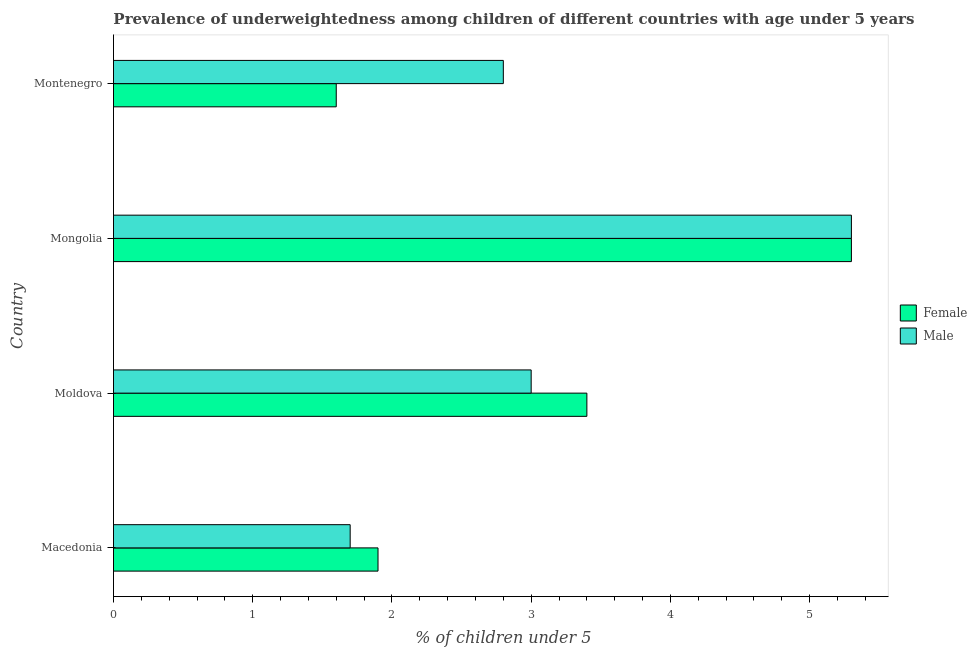How many different coloured bars are there?
Offer a very short reply. 2. Are the number of bars on each tick of the Y-axis equal?
Your answer should be very brief. Yes. How many bars are there on the 1st tick from the bottom?
Provide a short and direct response. 2. What is the label of the 1st group of bars from the top?
Keep it short and to the point. Montenegro. In how many cases, is the number of bars for a given country not equal to the number of legend labels?
Make the answer very short. 0. What is the percentage of underweighted male children in Moldova?
Your answer should be compact. 3. Across all countries, what is the maximum percentage of underweighted male children?
Your answer should be very brief. 5.3. Across all countries, what is the minimum percentage of underweighted female children?
Offer a very short reply. 1.6. In which country was the percentage of underweighted female children maximum?
Your answer should be compact. Mongolia. In which country was the percentage of underweighted female children minimum?
Your response must be concise. Montenegro. What is the total percentage of underweighted male children in the graph?
Offer a very short reply. 12.8. What is the difference between the percentage of underweighted male children in Moldova and that in Montenegro?
Provide a succinct answer. 0.2. What is the difference between the percentage of underweighted male children in Mongolia and the percentage of underweighted female children in Macedonia?
Your answer should be compact. 3.4. What is the average percentage of underweighted male children per country?
Keep it short and to the point. 3.2. What is the ratio of the percentage of underweighted female children in Macedonia to that in Mongolia?
Keep it short and to the point. 0.36. Is the percentage of underweighted female children in Macedonia less than that in Moldova?
Provide a succinct answer. Yes. Is the difference between the percentage of underweighted female children in Moldova and Mongolia greater than the difference between the percentage of underweighted male children in Moldova and Mongolia?
Your response must be concise. Yes. In how many countries, is the percentage of underweighted female children greater than the average percentage of underweighted female children taken over all countries?
Offer a very short reply. 2. Is the sum of the percentage of underweighted male children in Moldova and Mongolia greater than the maximum percentage of underweighted female children across all countries?
Your response must be concise. Yes. What does the 1st bar from the top in Montenegro represents?
Your response must be concise. Male. What does the 2nd bar from the bottom in Montenegro represents?
Make the answer very short. Male. How many bars are there?
Provide a succinct answer. 8. Are all the bars in the graph horizontal?
Offer a very short reply. Yes. Does the graph contain any zero values?
Your response must be concise. No. Where does the legend appear in the graph?
Offer a terse response. Center right. What is the title of the graph?
Keep it short and to the point. Prevalence of underweightedness among children of different countries with age under 5 years. Does "Canada" appear as one of the legend labels in the graph?
Your response must be concise. No. What is the label or title of the X-axis?
Offer a very short reply.  % of children under 5. What is the label or title of the Y-axis?
Offer a very short reply. Country. What is the  % of children under 5 in Female in Macedonia?
Offer a terse response. 1.9. What is the  % of children under 5 in Male in Macedonia?
Your response must be concise. 1.7. What is the  % of children under 5 of Female in Moldova?
Keep it short and to the point. 3.4. What is the  % of children under 5 of Female in Mongolia?
Offer a terse response. 5.3. What is the  % of children under 5 of Male in Mongolia?
Offer a very short reply. 5.3. What is the  % of children under 5 in Female in Montenegro?
Offer a very short reply. 1.6. What is the  % of children under 5 in Male in Montenegro?
Your answer should be compact. 2.8. Across all countries, what is the maximum  % of children under 5 of Female?
Provide a short and direct response. 5.3. Across all countries, what is the maximum  % of children under 5 of Male?
Your response must be concise. 5.3. Across all countries, what is the minimum  % of children under 5 in Female?
Your response must be concise. 1.6. Across all countries, what is the minimum  % of children under 5 in Male?
Provide a short and direct response. 1.7. What is the total  % of children under 5 in Female in the graph?
Give a very brief answer. 12.2. What is the difference between the  % of children under 5 of Male in Macedonia and that in Moldova?
Ensure brevity in your answer.  -1.3. What is the difference between the  % of children under 5 of Female in Macedonia and that in Mongolia?
Make the answer very short. -3.4. What is the difference between the  % of children under 5 in Male in Macedonia and that in Mongolia?
Provide a succinct answer. -3.6. What is the difference between the  % of children under 5 of Female in Macedonia and that in Montenegro?
Keep it short and to the point. 0.3. What is the difference between the  % of children under 5 of Male in Macedonia and that in Montenegro?
Offer a very short reply. -1.1. What is the difference between the  % of children under 5 of Male in Moldova and that in Mongolia?
Your answer should be compact. -2.3. What is the difference between the  % of children under 5 of Female in Moldova and that in Montenegro?
Your answer should be very brief. 1.8. What is the difference between the  % of children under 5 of Male in Moldova and that in Montenegro?
Ensure brevity in your answer.  0.2. What is the difference between the  % of children under 5 of Female in Mongolia and that in Montenegro?
Provide a short and direct response. 3.7. What is the difference between the  % of children under 5 in Male in Mongolia and that in Montenegro?
Offer a very short reply. 2.5. What is the difference between the  % of children under 5 of Female in Macedonia and the  % of children under 5 of Male in Mongolia?
Keep it short and to the point. -3.4. What is the difference between the  % of children under 5 of Female in Moldova and the  % of children under 5 of Male in Montenegro?
Your answer should be very brief. 0.6. What is the average  % of children under 5 of Female per country?
Provide a succinct answer. 3.05. What is the difference between the  % of children under 5 in Female and  % of children under 5 in Male in Macedonia?
Your answer should be very brief. 0.2. What is the difference between the  % of children under 5 in Female and  % of children under 5 in Male in Mongolia?
Give a very brief answer. 0. What is the difference between the  % of children under 5 in Female and  % of children under 5 in Male in Montenegro?
Make the answer very short. -1.2. What is the ratio of the  % of children under 5 in Female in Macedonia to that in Moldova?
Keep it short and to the point. 0.56. What is the ratio of the  % of children under 5 of Male in Macedonia to that in Moldova?
Give a very brief answer. 0.57. What is the ratio of the  % of children under 5 of Female in Macedonia to that in Mongolia?
Your response must be concise. 0.36. What is the ratio of the  % of children under 5 of Male in Macedonia to that in Mongolia?
Give a very brief answer. 0.32. What is the ratio of the  % of children under 5 in Female in Macedonia to that in Montenegro?
Ensure brevity in your answer.  1.19. What is the ratio of the  % of children under 5 of Male in Macedonia to that in Montenegro?
Offer a terse response. 0.61. What is the ratio of the  % of children under 5 in Female in Moldova to that in Mongolia?
Your answer should be very brief. 0.64. What is the ratio of the  % of children under 5 in Male in Moldova to that in Mongolia?
Provide a succinct answer. 0.57. What is the ratio of the  % of children under 5 of Female in Moldova to that in Montenegro?
Your response must be concise. 2.12. What is the ratio of the  % of children under 5 in Male in Moldova to that in Montenegro?
Give a very brief answer. 1.07. What is the ratio of the  % of children under 5 of Female in Mongolia to that in Montenegro?
Your answer should be very brief. 3.31. What is the ratio of the  % of children under 5 in Male in Mongolia to that in Montenegro?
Make the answer very short. 1.89. What is the difference between the highest and the second highest  % of children under 5 of Female?
Your answer should be very brief. 1.9. What is the difference between the highest and the lowest  % of children under 5 of Female?
Your answer should be very brief. 3.7. 